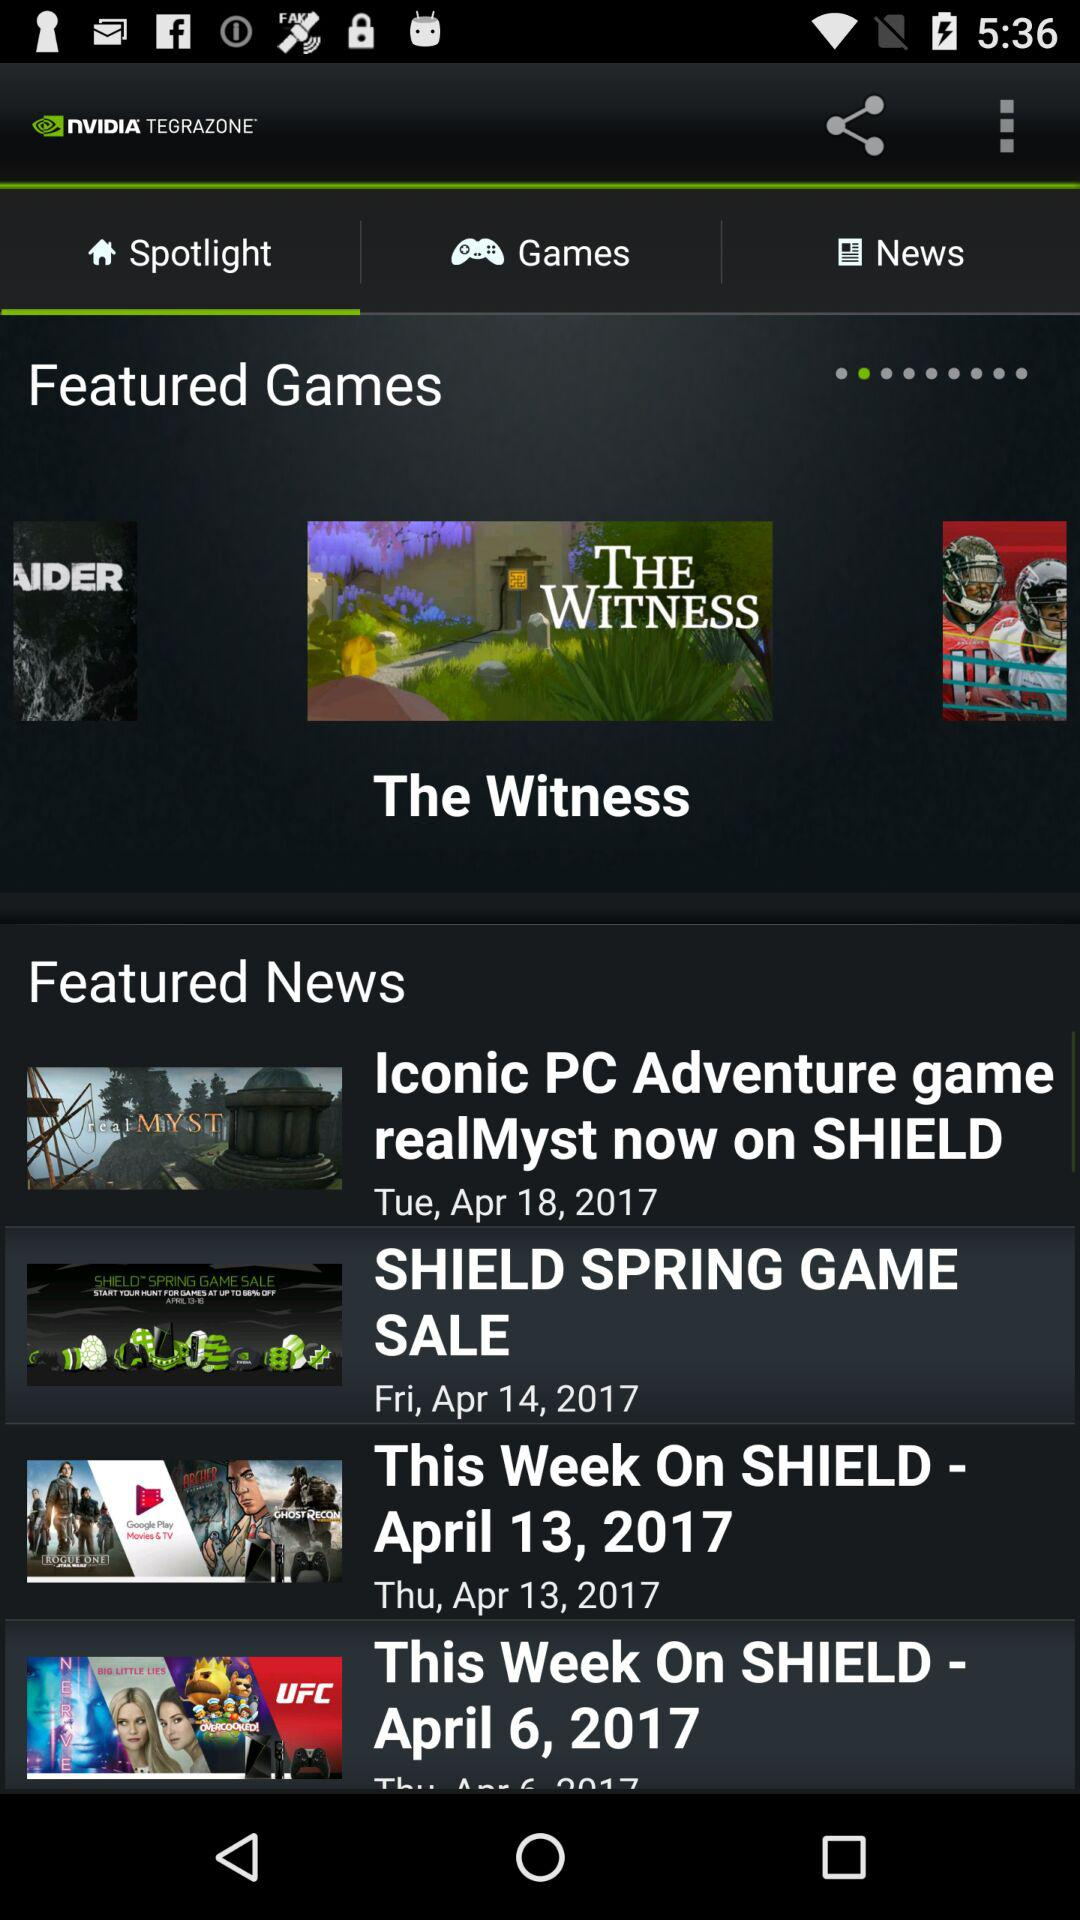When was the news about the shield spring game posted? The news about the shield spring game was posted on Friday, April 14, 2017. 